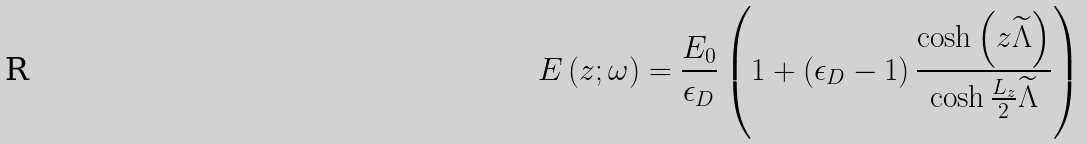Convert formula to latex. <formula><loc_0><loc_0><loc_500><loc_500>E \left ( z ; \omega \right ) = \frac { E _ { 0 } } { \epsilon _ { D } } \left ( 1 + \left ( \epsilon _ { D } - 1 \right ) \frac { \cosh \left ( z \widetilde { \Lambda } \right ) } { \cosh \frac { L _ { z } } { 2 } \widetilde { \Lambda } } \right )</formula> 